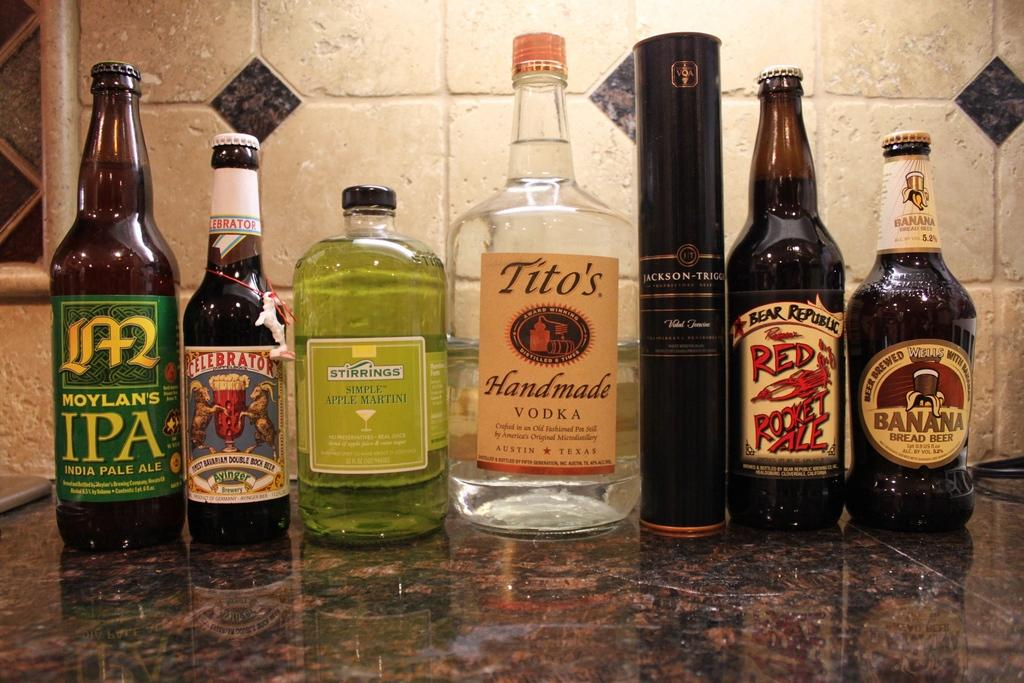<image>
Render a clear and concise summary of the photo. A variety of bottles of various flavors of liquor and beer with one of them being Tito's Handmade Vodka. 